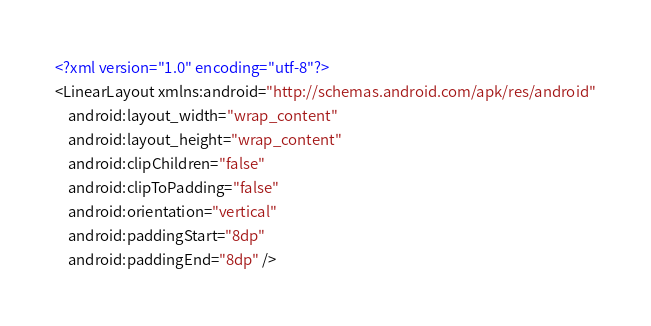<code> <loc_0><loc_0><loc_500><loc_500><_XML_><?xml version="1.0" encoding="utf-8"?>
<LinearLayout xmlns:android="http://schemas.android.com/apk/res/android"
    android:layout_width="wrap_content"
    android:layout_height="wrap_content"
    android:clipChildren="false"
    android:clipToPadding="false"
    android:orientation="vertical"
    android:paddingStart="8dp"
    android:paddingEnd="8dp" />
</code> 